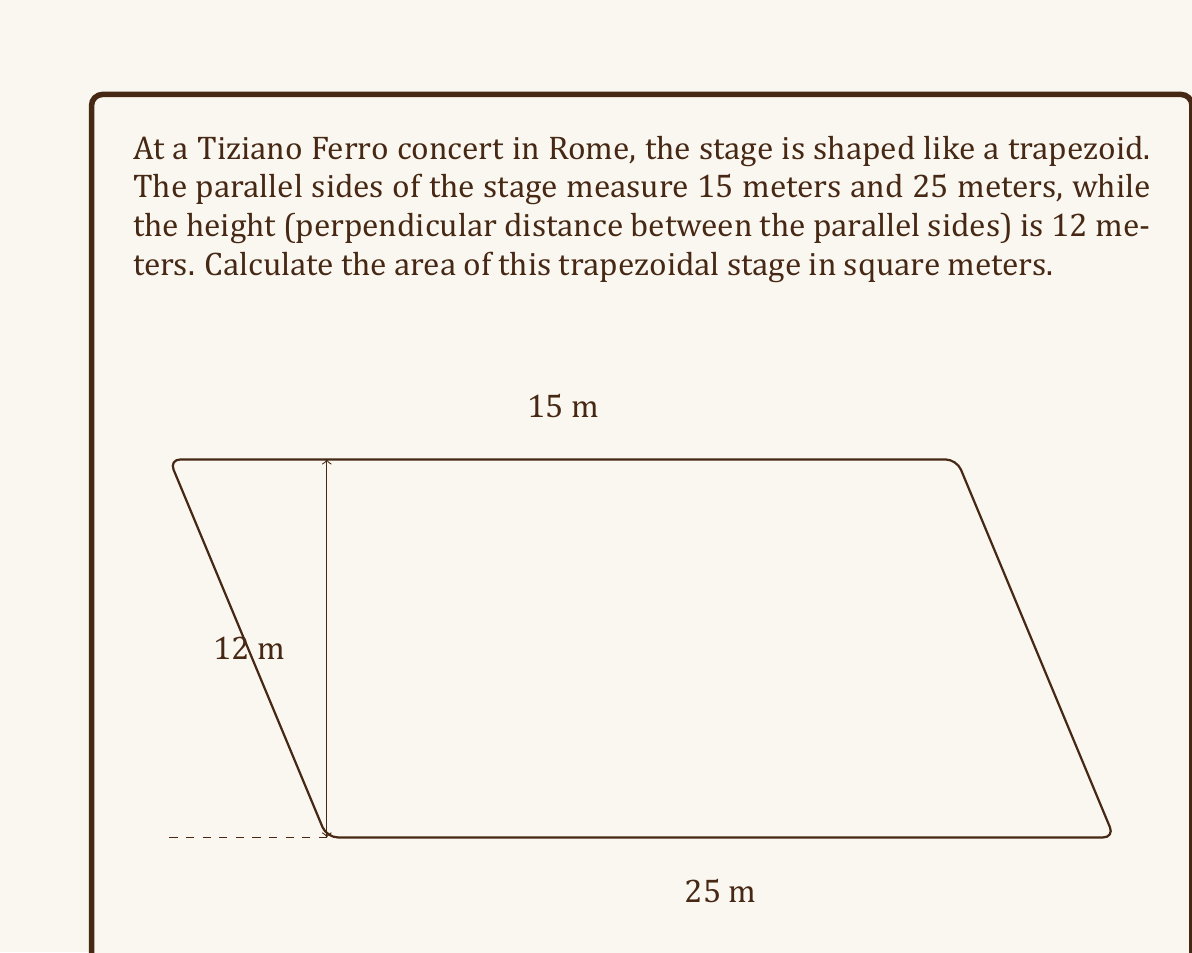Help me with this question. Let's approach this step-by-step:

1) The formula for the area of a trapezoid is:

   $$ A = \frac{1}{2}(b_1 + b_2)h $$

   where $A$ is the area, $b_1$ and $b_2$ are the lengths of the parallel sides, and $h$ is the height.

2) In this case:
   $b_1 = 15$ meters (shorter parallel side)
   $b_2 = 25$ meters (longer parallel side)
   $h = 12$ meters (height)

3) Let's substitute these values into the formula:

   $$ A = \frac{1}{2}(15 + 25) \cdot 12 $$

4) First, add the parallel sides:
   
   $$ A = \frac{1}{2}(40) \cdot 12 $$

5) Multiply:
   
   $$ A = 20 \cdot 12 = 240 $$

Therefore, the area of the trapezoidal stage is 240 square meters.
Answer: 240 m² 